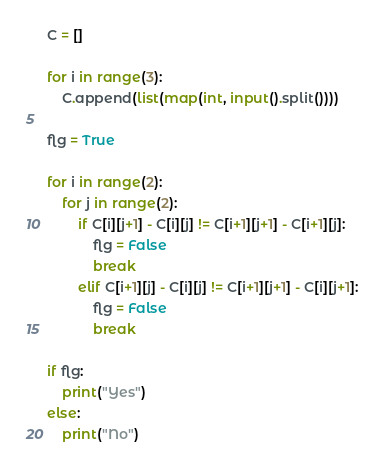Convert code to text. <code><loc_0><loc_0><loc_500><loc_500><_Python_>C = []

for i in range(3):
    C.append(list(map(int, input().split())))

flg = True

for i in range(2):
    for j in range(2):
        if C[i][j+1] - C[i][j] != C[i+1][j+1] - C[i+1][j]:
            flg = False
            break
        elif C[i+1][j] - C[i][j] != C[i+1][j+1] - C[i][j+1]:
            flg = False
            break

if flg:
    print("Yes")
else:
    print("No")</code> 